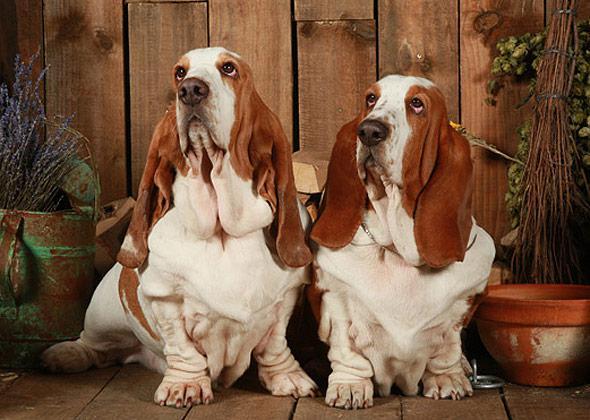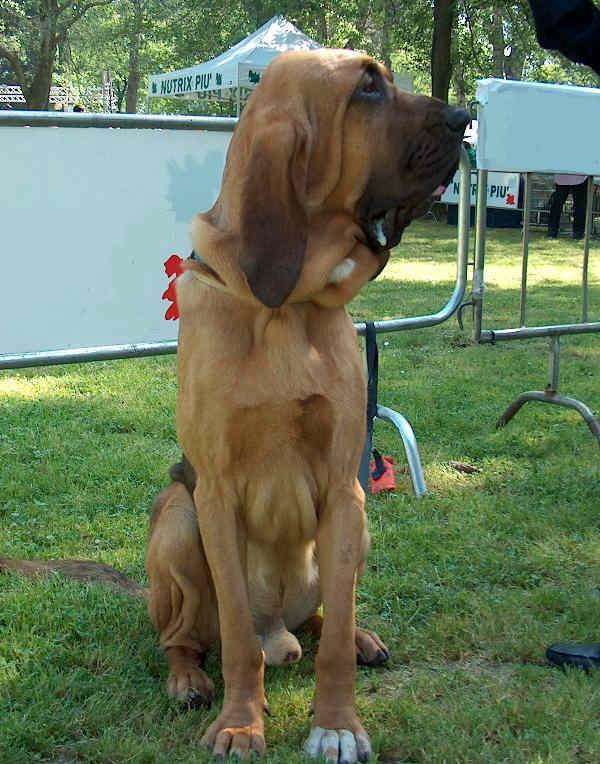The first image is the image on the left, the second image is the image on the right. Analyze the images presented: Is the assertion "An image contains exactly one basset hound, which has tan and white coloring." valid? Answer yes or no. No. The first image is the image on the left, the second image is the image on the right. Considering the images on both sides, is "There are at least two dogs sitting in the image on the left." valid? Answer yes or no. Yes. 